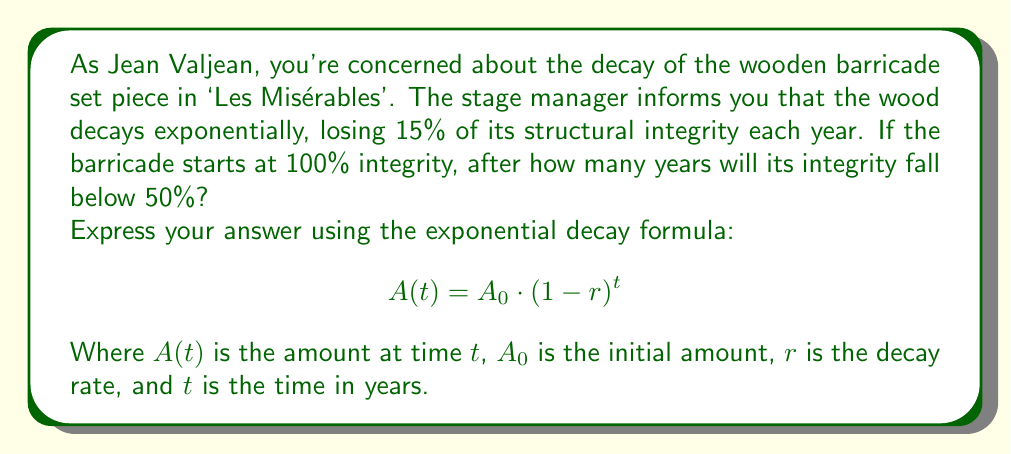Help me with this question. To solve this problem, we'll use the exponential decay formula:

$$A(t) = A_0 \cdot (1-r)^t$$

Where:
$A(t)$ = 50% (the target integrity)
$A_0$ = 100% (initial integrity)
$r$ = 15% = 0.15 (decay rate)
$t$ = unknown (time in years)

Let's substitute these values:

$$50 = 100 \cdot (1-0.15)^t$$

Simplify:

$$0.5 = (0.85)^t$$

Now, we need to solve for $t$. We can do this using logarithms:

$$\ln(0.5) = \ln((0.85)^t)$$
$$\ln(0.5) = t \cdot \ln(0.85)$$

Solve for $t$:

$$t = \frac{\ln(0.5)}{\ln(0.85)}$$

Using a calculator:

$$t \approx 4.27 \text{ years}$$

Since we can't have a fractional year in this context, we round up to the next whole year.
Answer: The integrity of the wooden barricade set piece will fall below 50% after 5 years. 